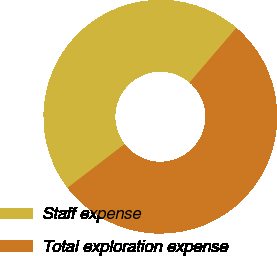Convert chart. <chart><loc_0><loc_0><loc_500><loc_500><pie_chart><fcel>Staff expense<fcel>Total exploration expense<nl><fcel>46.67%<fcel>53.33%<nl></chart> 